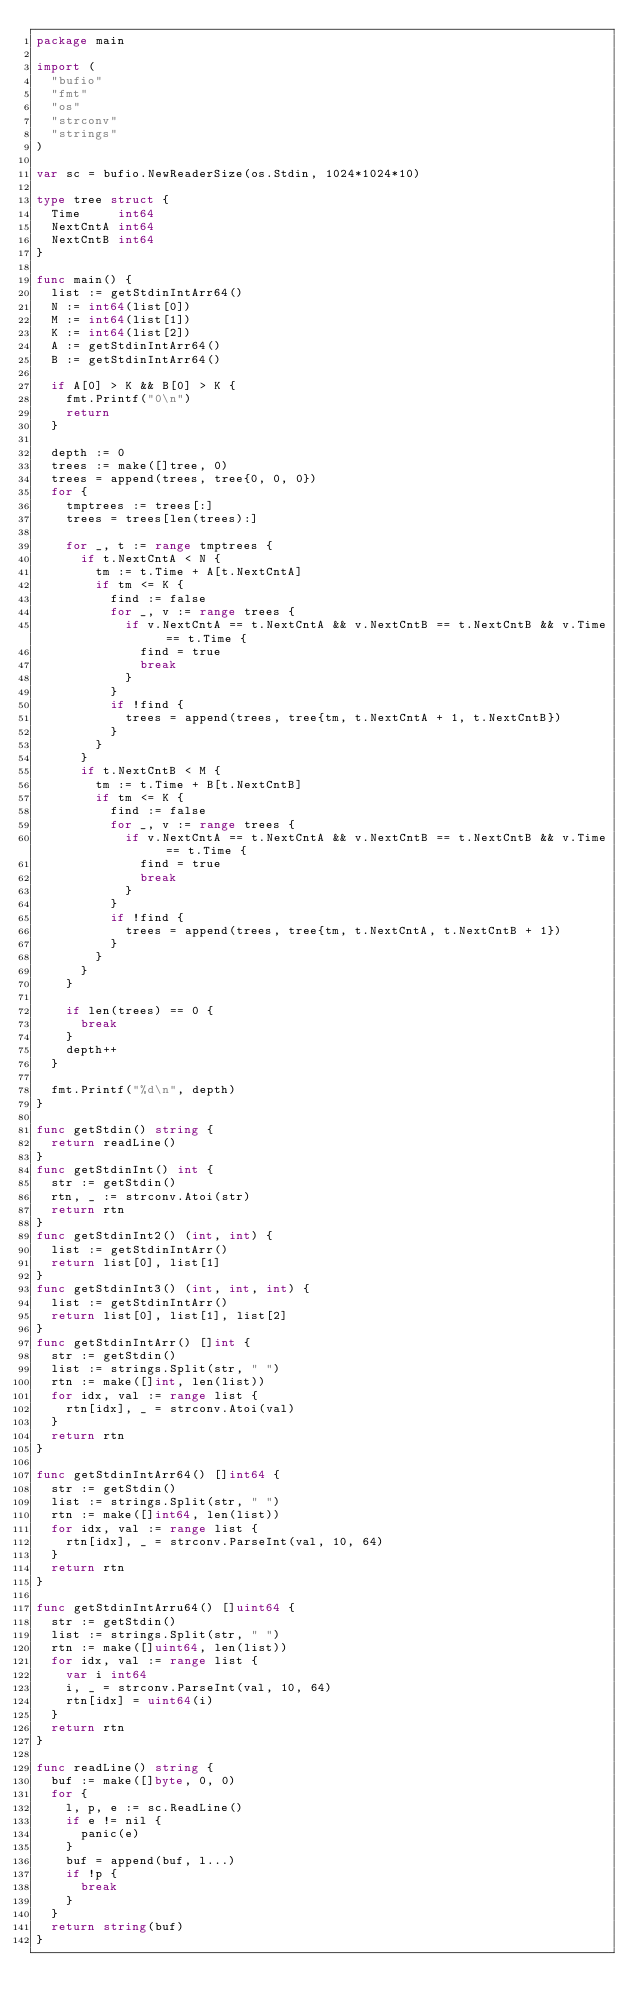<code> <loc_0><loc_0><loc_500><loc_500><_Go_>package main

import (
	"bufio"
	"fmt"
	"os"
	"strconv"
	"strings"
)

var sc = bufio.NewReaderSize(os.Stdin, 1024*1024*10)

type tree struct {
	Time     int64
	NextCntA int64
	NextCntB int64
}

func main() {
	list := getStdinIntArr64()
	N := int64(list[0])
	M := int64(list[1])
	K := int64(list[2])
	A := getStdinIntArr64()
	B := getStdinIntArr64()

	if A[0] > K && B[0] > K {
		fmt.Printf("0\n")
		return
	}

	depth := 0
	trees := make([]tree, 0)
	trees = append(trees, tree{0, 0, 0})
	for {
		tmptrees := trees[:]
		trees = trees[len(trees):]

		for _, t := range tmptrees {
			if t.NextCntA < N {
				tm := t.Time + A[t.NextCntA]
				if tm <= K {
					find := false
					for _, v := range trees {
						if v.NextCntA == t.NextCntA && v.NextCntB == t.NextCntB && v.Time == t.Time {
							find = true
							break
						}
					}
					if !find {
						trees = append(trees, tree{tm, t.NextCntA + 1, t.NextCntB})
					}
				}
			}
			if t.NextCntB < M {
				tm := t.Time + B[t.NextCntB]
				if tm <= K {
					find := false
					for _, v := range trees {
						if v.NextCntA == t.NextCntA && v.NextCntB == t.NextCntB && v.Time == t.Time {
							find = true
							break
						}
					}
					if !find {
						trees = append(trees, tree{tm, t.NextCntA, t.NextCntB + 1})
					}
				}
			}
		}

		if len(trees) == 0 {
			break
		}
		depth++
	}

	fmt.Printf("%d\n", depth)
}

func getStdin() string {
	return readLine()
}
func getStdinInt() int {
	str := getStdin()
	rtn, _ := strconv.Atoi(str)
	return rtn
}
func getStdinInt2() (int, int) {
	list := getStdinIntArr()
	return list[0], list[1]
}
func getStdinInt3() (int, int, int) {
	list := getStdinIntArr()
	return list[0], list[1], list[2]
}
func getStdinIntArr() []int {
	str := getStdin()
	list := strings.Split(str, " ")
	rtn := make([]int, len(list))
	for idx, val := range list {
		rtn[idx], _ = strconv.Atoi(val)
	}
	return rtn
}

func getStdinIntArr64() []int64 {
	str := getStdin()
	list := strings.Split(str, " ")
	rtn := make([]int64, len(list))
	for idx, val := range list {
		rtn[idx], _ = strconv.ParseInt(val, 10, 64)
	}
	return rtn
}

func getStdinIntArru64() []uint64 {
	str := getStdin()
	list := strings.Split(str, " ")
	rtn := make([]uint64, len(list))
	for idx, val := range list {
		var i int64
		i, _ = strconv.ParseInt(val, 10, 64)
		rtn[idx] = uint64(i)
	}
	return rtn
}

func readLine() string {
	buf := make([]byte, 0, 0)
	for {
		l, p, e := sc.ReadLine()
		if e != nil {
			panic(e)
		}
		buf = append(buf, l...)
		if !p {
			break
		}
	}
	return string(buf)
}
</code> 